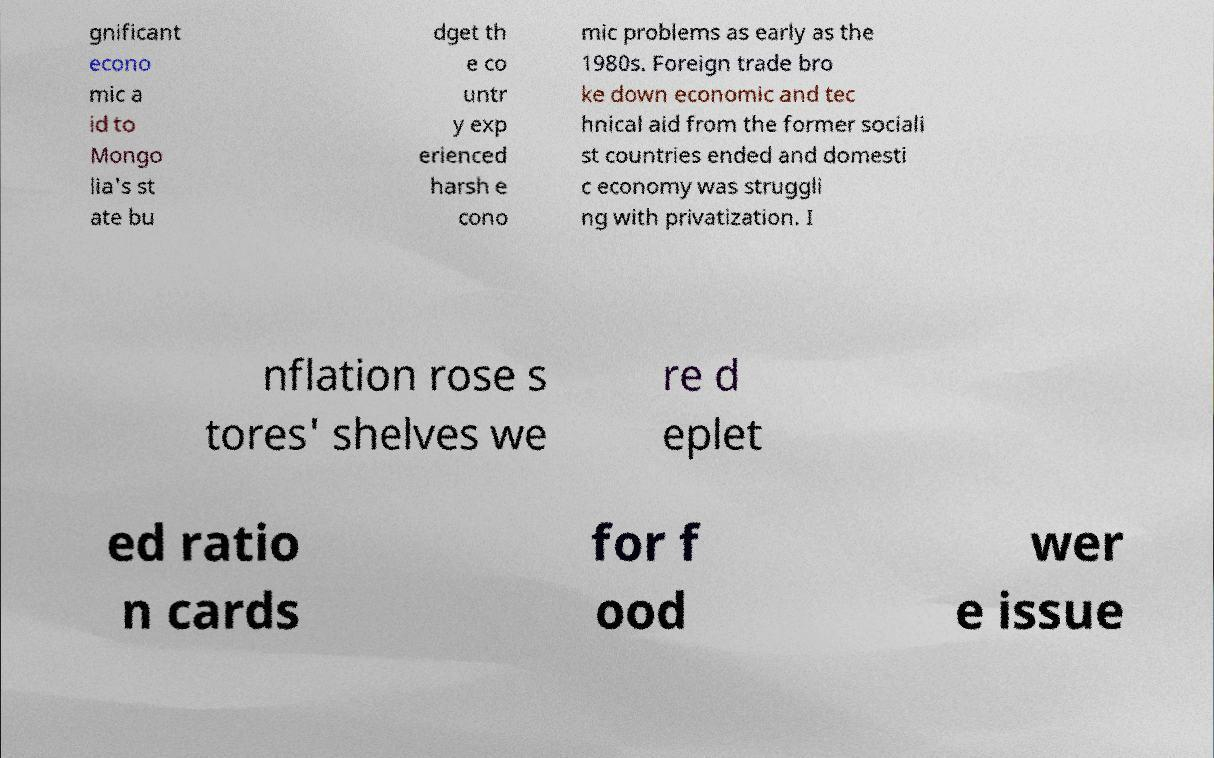I need the written content from this picture converted into text. Can you do that? gnificant econo mic a id to Mongo lia's st ate bu dget th e co untr y exp erienced harsh e cono mic problems as early as the 1980s. Foreign trade bro ke down economic and tec hnical aid from the former sociali st countries ended and domesti c economy was struggli ng with privatization. I nflation rose s tores' shelves we re d eplet ed ratio n cards for f ood wer e issue 